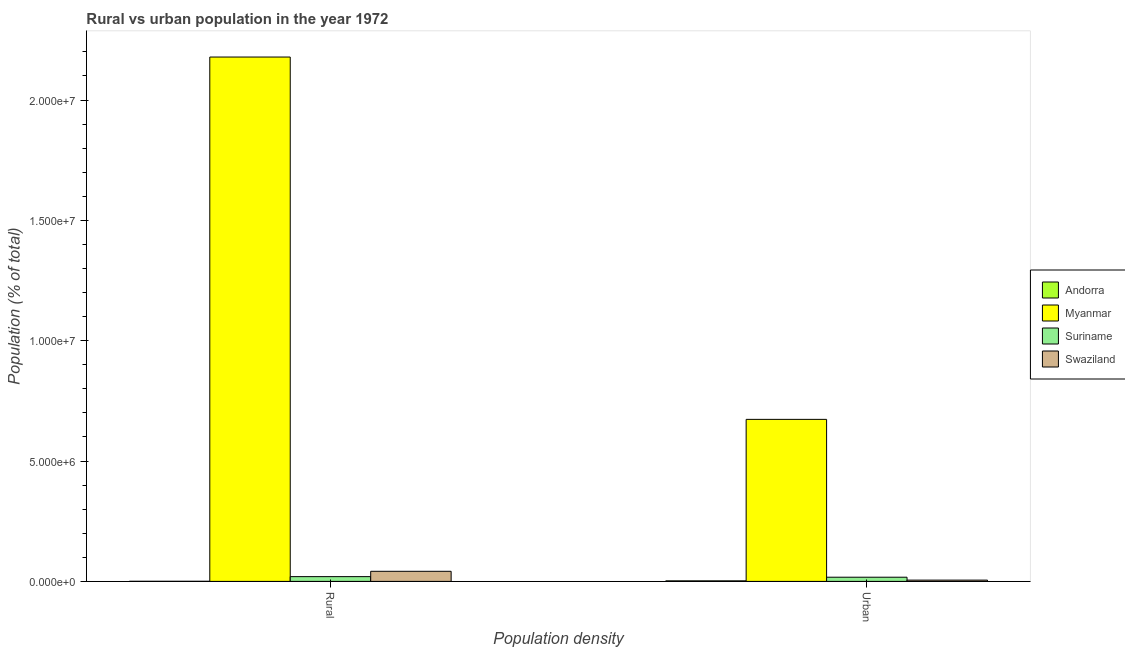Are the number of bars on each tick of the X-axis equal?
Ensure brevity in your answer.  Yes. How many bars are there on the 1st tick from the left?
Make the answer very short. 4. What is the label of the 2nd group of bars from the left?
Ensure brevity in your answer.  Urban. What is the rural population density in Suriname?
Provide a succinct answer. 1.98e+05. Across all countries, what is the maximum urban population density?
Keep it short and to the point. 6.73e+06. Across all countries, what is the minimum rural population density?
Provide a succinct answer. 4491. In which country was the urban population density maximum?
Your response must be concise. Myanmar. In which country was the urban population density minimum?
Make the answer very short. Andorra. What is the total rural population density in the graph?
Provide a succinct answer. 2.24e+07. What is the difference between the rural population density in Swaziland and that in Suriname?
Make the answer very short. 2.21e+05. What is the difference between the urban population density in Andorra and the rural population density in Suriname?
Your answer should be compact. -1.75e+05. What is the average rural population density per country?
Offer a terse response. 5.60e+06. What is the difference between the urban population density and rural population density in Myanmar?
Offer a terse response. -1.51e+07. What is the ratio of the urban population density in Suriname to that in Swaziland?
Your answer should be compact. 3.26. What does the 4th bar from the left in Urban represents?
Your answer should be compact. Swaziland. What does the 2nd bar from the right in Urban represents?
Your response must be concise. Suriname. Does the graph contain any zero values?
Offer a terse response. No. Where does the legend appear in the graph?
Your response must be concise. Center right. How many legend labels are there?
Offer a terse response. 4. How are the legend labels stacked?
Ensure brevity in your answer.  Vertical. What is the title of the graph?
Ensure brevity in your answer.  Rural vs urban population in the year 1972. What is the label or title of the X-axis?
Offer a very short reply. Population density. What is the label or title of the Y-axis?
Make the answer very short. Population (% of total). What is the Population (% of total) in Andorra in Rural?
Keep it short and to the point. 4491. What is the Population (% of total) in Myanmar in Rural?
Provide a succinct answer. 2.18e+07. What is the Population (% of total) in Suriname in Rural?
Offer a terse response. 1.98e+05. What is the Population (% of total) of Swaziland in Rural?
Make the answer very short. 4.19e+05. What is the Population (% of total) in Andorra in Urban?
Keep it short and to the point. 2.24e+04. What is the Population (% of total) in Myanmar in Urban?
Your response must be concise. 6.73e+06. What is the Population (% of total) in Suriname in Urban?
Offer a terse response. 1.74e+05. What is the Population (% of total) in Swaziland in Urban?
Ensure brevity in your answer.  5.32e+04. Across all Population density, what is the maximum Population (% of total) of Andorra?
Keep it short and to the point. 2.24e+04. Across all Population density, what is the maximum Population (% of total) in Myanmar?
Offer a very short reply. 2.18e+07. Across all Population density, what is the maximum Population (% of total) of Suriname?
Give a very brief answer. 1.98e+05. Across all Population density, what is the maximum Population (% of total) of Swaziland?
Keep it short and to the point. 4.19e+05. Across all Population density, what is the minimum Population (% of total) of Andorra?
Your answer should be very brief. 4491. Across all Population density, what is the minimum Population (% of total) in Myanmar?
Ensure brevity in your answer.  6.73e+06. Across all Population density, what is the minimum Population (% of total) in Suriname?
Provide a short and direct response. 1.74e+05. Across all Population density, what is the minimum Population (% of total) in Swaziland?
Your response must be concise. 5.32e+04. What is the total Population (% of total) in Andorra in the graph?
Your response must be concise. 2.69e+04. What is the total Population (% of total) of Myanmar in the graph?
Make the answer very short. 2.85e+07. What is the total Population (% of total) of Suriname in the graph?
Ensure brevity in your answer.  3.71e+05. What is the total Population (% of total) of Swaziland in the graph?
Your answer should be very brief. 4.72e+05. What is the difference between the Population (% of total) in Andorra in Rural and that in Urban?
Offer a terse response. -1.79e+04. What is the difference between the Population (% of total) in Myanmar in Rural and that in Urban?
Give a very brief answer. 1.51e+07. What is the difference between the Population (% of total) in Suriname in Rural and that in Urban?
Your answer should be very brief. 2.41e+04. What is the difference between the Population (% of total) in Swaziland in Rural and that in Urban?
Ensure brevity in your answer.  3.66e+05. What is the difference between the Population (% of total) of Andorra in Rural and the Population (% of total) of Myanmar in Urban?
Ensure brevity in your answer.  -6.73e+06. What is the difference between the Population (% of total) in Andorra in Rural and the Population (% of total) in Suriname in Urban?
Give a very brief answer. -1.69e+05. What is the difference between the Population (% of total) in Andorra in Rural and the Population (% of total) in Swaziland in Urban?
Offer a very short reply. -4.87e+04. What is the difference between the Population (% of total) in Myanmar in Rural and the Population (% of total) in Suriname in Urban?
Your answer should be very brief. 2.16e+07. What is the difference between the Population (% of total) in Myanmar in Rural and the Population (% of total) in Swaziland in Urban?
Your answer should be compact. 2.17e+07. What is the difference between the Population (% of total) of Suriname in Rural and the Population (% of total) of Swaziland in Urban?
Provide a short and direct response. 1.44e+05. What is the average Population (% of total) in Andorra per Population density?
Your answer should be very brief. 1.34e+04. What is the average Population (% of total) in Myanmar per Population density?
Make the answer very short. 1.43e+07. What is the average Population (% of total) in Suriname per Population density?
Ensure brevity in your answer.  1.86e+05. What is the average Population (% of total) of Swaziland per Population density?
Make the answer very short. 2.36e+05. What is the difference between the Population (% of total) of Andorra and Population (% of total) of Myanmar in Rural?
Keep it short and to the point. -2.18e+07. What is the difference between the Population (% of total) in Andorra and Population (% of total) in Suriname in Rural?
Provide a succinct answer. -1.93e+05. What is the difference between the Population (% of total) of Andorra and Population (% of total) of Swaziland in Rural?
Provide a succinct answer. -4.15e+05. What is the difference between the Population (% of total) in Myanmar and Population (% of total) in Suriname in Rural?
Your response must be concise. 2.16e+07. What is the difference between the Population (% of total) in Myanmar and Population (% of total) in Swaziland in Rural?
Ensure brevity in your answer.  2.14e+07. What is the difference between the Population (% of total) in Suriname and Population (% of total) in Swaziland in Rural?
Give a very brief answer. -2.21e+05. What is the difference between the Population (% of total) in Andorra and Population (% of total) in Myanmar in Urban?
Provide a short and direct response. -6.71e+06. What is the difference between the Population (% of total) in Andorra and Population (% of total) in Suriname in Urban?
Ensure brevity in your answer.  -1.51e+05. What is the difference between the Population (% of total) in Andorra and Population (% of total) in Swaziland in Urban?
Your answer should be very brief. -3.08e+04. What is the difference between the Population (% of total) in Myanmar and Population (% of total) in Suriname in Urban?
Provide a short and direct response. 6.56e+06. What is the difference between the Population (% of total) of Myanmar and Population (% of total) of Swaziland in Urban?
Offer a very short reply. 6.68e+06. What is the difference between the Population (% of total) of Suriname and Population (% of total) of Swaziland in Urban?
Give a very brief answer. 1.20e+05. What is the ratio of the Population (% of total) in Andorra in Rural to that in Urban?
Make the answer very short. 0.2. What is the ratio of the Population (% of total) of Myanmar in Rural to that in Urban?
Your answer should be compact. 3.24. What is the ratio of the Population (% of total) in Suriname in Rural to that in Urban?
Your answer should be compact. 1.14. What is the ratio of the Population (% of total) of Swaziland in Rural to that in Urban?
Offer a terse response. 7.88. What is the difference between the highest and the second highest Population (% of total) of Andorra?
Keep it short and to the point. 1.79e+04. What is the difference between the highest and the second highest Population (% of total) of Myanmar?
Provide a succinct answer. 1.51e+07. What is the difference between the highest and the second highest Population (% of total) in Suriname?
Make the answer very short. 2.41e+04. What is the difference between the highest and the second highest Population (% of total) in Swaziland?
Keep it short and to the point. 3.66e+05. What is the difference between the highest and the lowest Population (% of total) of Andorra?
Offer a terse response. 1.79e+04. What is the difference between the highest and the lowest Population (% of total) of Myanmar?
Give a very brief answer. 1.51e+07. What is the difference between the highest and the lowest Population (% of total) in Suriname?
Provide a short and direct response. 2.41e+04. What is the difference between the highest and the lowest Population (% of total) of Swaziland?
Give a very brief answer. 3.66e+05. 